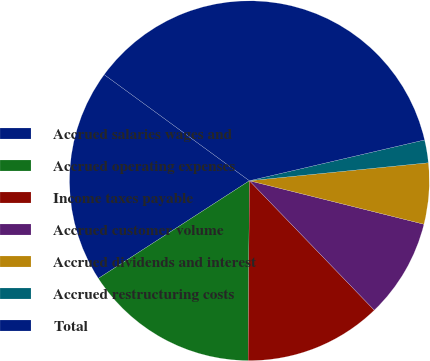Convert chart. <chart><loc_0><loc_0><loc_500><loc_500><pie_chart><fcel>Accrued salaries wages and<fcel>Accrued operating expenses<fcel>Income taxes payable<fcel>Accrued customer volume<fcel>Accrued dividends and interest<fcel>Accrued restructuring costs<fcel>Total<nl><fcel>19.18%<fcel>15.75%<fcel>12.33%<fcel>8.9%<fcel>5.48%<fcel>2.05%<fcel>36.31%<nl></chart> 